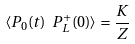<formula> <loc_0><loc_0><loc_500><loc_500>\langle P _ { 0 } ( t ) \ P ^ { + } _ { L } ( 0 ) \rangle = \frac { K } { Z }</formula> 